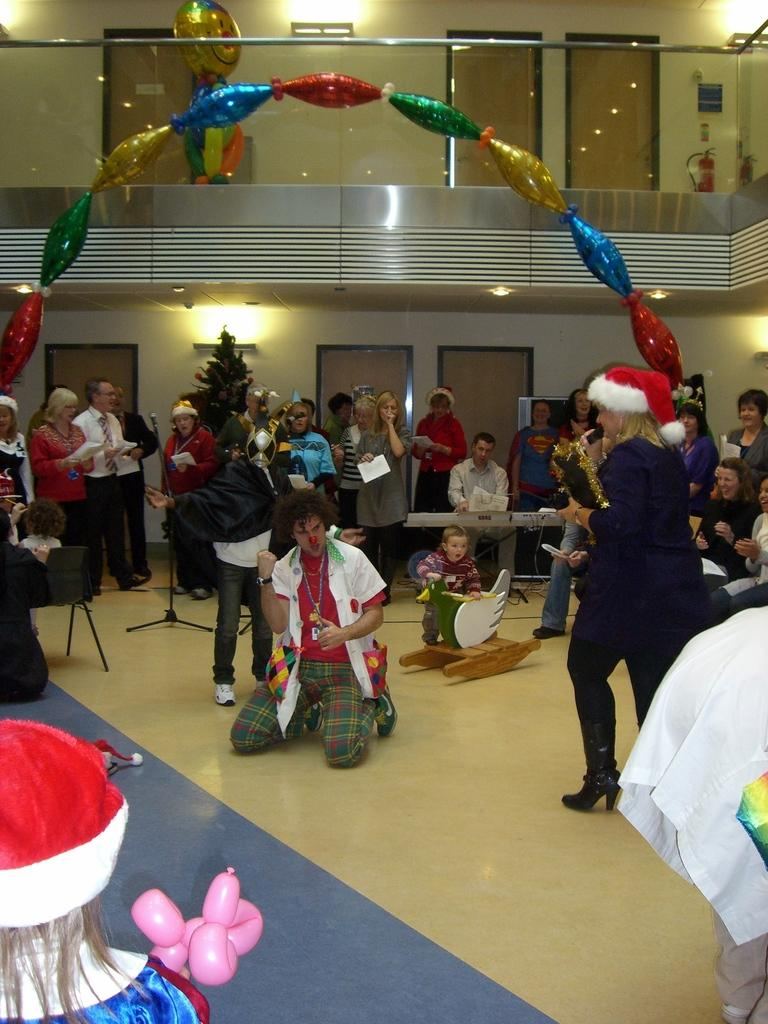How many people are in the image? There are people in the image, but the exact number is not specified. What are some of the people doing in the image? Some of the people are sitting, and some are standing. What decorative elements can be seen in the image? There are balloons, doors, and lights in the image. What color are the walls in the image? The walls are cream-colored. What natural element is present in the image? There is a tree in the image. How many babies are playing on the playground in the image? There is no playground or babies present in the image. What type of lumber is being used to construct the doors in the image? The facts do not mention the type of lumber used for the doors, and there is no indication of any construction work in the image. 